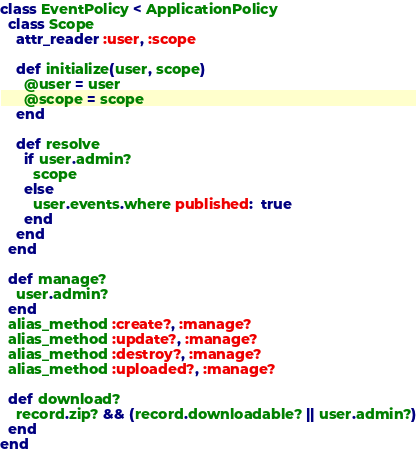<code> <loc_0><loc_0><loc_500><loc_500><_Ruby_>class EventPolicy < ApplicationPolicy
  class Scope
    attr_reader :user, :scope

    def initialize(user, scope)
      @user = user
      @scope = scope
    end

    def resolve
      if user.admin?
        scope
      else
        user.events.where published:  true
      end
    end
  end

  def manage?
    user.admin?
  end
  alias_method :create?, :manage?
  alias_method :update?, :manage?
  alias_method :destroy?, :manage?
  alias_method :uploaded?, :manage?

  def download?
    record.zip? && (record.downloadable? || user.admin?)
  end
end
</code> 